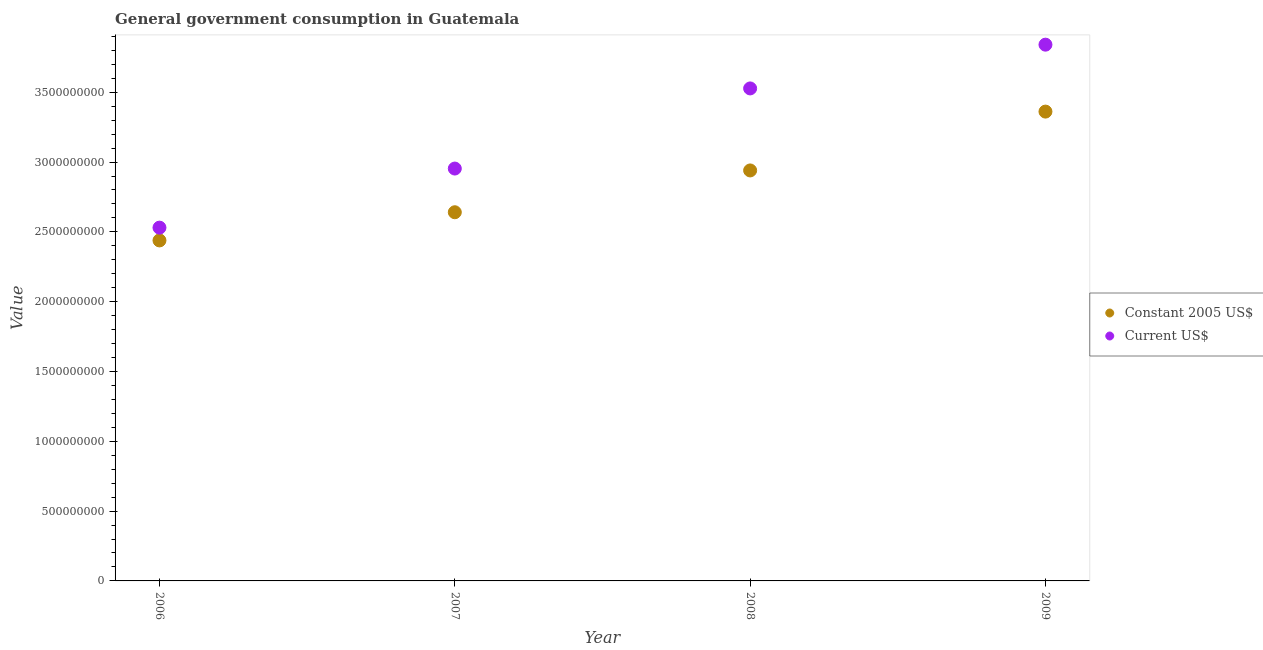What is the value consumed in current us$ in 2006?
Keep it short and to the point. 2.53e+09. Across all years, what is the maximum value consumed in constant 2005 us$?
Your response must be concise. 3.36e+09. Across all years, what is the minimum value consumed in constant 2005 us$?
Keep it short and to the point. 2.44e+09. In which year was the value consumed in current us$ maximum?
Provide a succinct answer. 2009. What is the total value consumed in constant 2005 us$ in the graph?
Provide a succinct answer. 1.14e+1. What is the difference between the value consumed in current us$ in 2006 and that in 2007?
Offer a very short reply. -4.23e+08. What is the difference between the value consumed in current us$ in 2007 and the value consumed in constant 2005 us$ in 2009?
Your answer should be very brief. -4.08e+08. What is the average value consumed in constant 2005 us$ per year?
Provide a short and direct response. 2.85e+09. In the year 2008, what is the difference between the value consumed in current us$ and value consumed in constant 2005 us$?
Your response must be concise. 5.87e+08. What is the ratio of the value consumed in constant 2005 us$ in 2008 to that in 2009?
Your answer should be compact. 0.87. Is the value consumed in current us$ in 2007 less than that in 2008?
Your answer should be very brief. Yes. Is the difference between the value consumed in constant 2005 us$ in 2006 and 2008 greater than the difference between the value consumed in current us$ in 2006 and 2008?
Provide a succinct answer. Yes. What is the difference between the highest and the second highest value consumed in constant 2005 us$?
Provide a short and direct response. 4.21e+08. What is the difference between the highest and the lowest value consumed in current us$?
Your response must be concise. 1.31e+09. In how many years, is the value consumed in current us$ greater than the average value consumed in current us$ taken over all years?
Offer a terse response. 2. Is the value consumed in current us$ strictly less than the value consumed in constant 2005 us$ over the years?
Make the answer very short. No. What is the difference between two consecutive major ticks on the Y-axis?
Your response must be concise. 5.00e+08. Are the values on the major ticks of Y-axis written in scientific E-notation?
Your answer should be compact. No. Does the graph contain grids?
Make the answer very short. No. Where does the legend appear in the graph?
Offer a very short reply. Center right. How many legend labels are there?
Offer a very short reply. 2. What is the title of the graph?
Keep it short and to the point. General government consumption in Guatemala. What is the label or title of the X-axis?
Give a very brief answer. Year. What is the label or title of the Y-axis?
Your answer should be compact. Value. What is the Value of Constant 2005 US$ in 2006?
Offer a terse response. 2.44e+09. What is the Value in Current US$ in 2006?
Give a very brief answer. 2.53e+09. What is the Value of Constant 2005 US$ in 2007?
Make the answer very short. 2.64e+09. What is the Value of Current US$ in 2007?
Ensure brevity in your answer.  2.95e+09. What is the Value of Constant 2005 US$ in 2008?
Offer a very short reply. 2.94e+09. What is the Value of Current US$ in 2008?
Your answer should be compact. 3.53e+09. What is the Value in Constant 2005 US$ in 2009?
Offer a terse response. 3.36e+09. What is the Value in Current US$ in 2009?
Your answer should be very brief. 3.84e+09. Across all years, what is the maximum Value in Constant 2005 US$?
Your answer should be very brief. 3.36e+09. Across all years, what is the maximum Value in Current US$?
Offer a terse response. 3.84e+09. Across all years, what is the minimum Value in Constant 2005 US$?
Give a very brief answer. 2.44e+09. Across all years, what is the minimum Value in Current US$?
Make the answer very short. 2.53e+09. What is the total Value of Constant 2005 US$ in the graph?
Your answer should be compact. 1.14e+1. What is the total Value in Current US$ in the graph?
Ensure brevity in your answer.  1.29e+1. What is the difference between the Value in Constant 2005 US$ in 2006 and that in 2007?
Make the answer very short. -2.02e+08. What is the difference between the Value in Current US$ in 2006 and that in 2007?
Make the answer very short. -4.23e+08. What is the difference between the Value of Constant 2005 US$ in 2006 and that in 2008?
Your answer should be very brief. -5.01e+08. What is the difference between the Value in Current US$ in 2006 and that in 2008?
Your answer should be very brief. -9.97e+08. What is the difference between the Value of Constant 2005 US$ in 2006 and that in 2009?
Offer a terse response. -9.23e+08. What is the difference between the Value of Current US$ in 2006 and that in 2009?
Keep it short and to the point. -1.31e+09. What is the difference between the Value of Constant 2005 US$ in 2007 and that in 2008?
Make the answer very short. -2.99e+08. What is the difference between the Value in Current US$ in 2007 and that in 2008?
Make the answer very short. -5.74e+08. What is the difference between the Value in Constant 2005 US$ in 2007 and that in 2009?
Ensure brevity in your answer.  -7.21e+08. What is the difference between the Value of Current US$ in 2007 and that in 2009?
Your answer should be compact. -8.87e+08. What is the difference between the Value in Constant 2005 US$ in 2008 and that in 2009?
Keep it short and to the point. -4.21e+08. What is the difference between the Value in Current US$ in 2008 and that in 2009?
Offer a terse response. -3.13e+08. What is the difference between the Value of Constant 2005 US$ in 2006 and the Value of Current US$ in 2007?
Provide a short and direct response. -5.15e+08. What is the difference between the Value in Constant 2005 US$ in 2006 and the Value in Current US$ in 2008?
Offer a very short reply. -1.09e+09. What is the difference between the Value of Constant 2005 US$ in 2006 and the Value of Current US$ in 2009?
Offer a terse response. -1.40e+09. What is the difference between the Value in Constant 2005 US$ in 2007 and the Value in Current US$ in 2008?
Your answer should be compact. -8.87e+08. What is the difference between the Value of Constant 2005 US$ in 2007 and the Value of Current US$ in 2009?
Ensure brevity in your answer.  -1.20e+09. What is the difference between the Value of Constant 2005 US$ in 2008 and the Value of Current US$ in 2009?
Provide a succinct answer. -9.01e+08. What is the average Value of Constant 2005 US$ per year?
Provide a short and direct response. 2.85e+09. What is the average Value in Current US$ per year?
Offer a very short reply. 3.21e+09. In the year 2006, what is the difference between the Value in Constant 2005 US$ and Value in Current US$?
Make the answer very short. -9.16e+07. In the year 2007, what is the difference between the Value of Constant 2005 US$ and Value of Current US$?
Offer a terse response. -3.13e+08. In the year 2008, what is the difference between the Value in Constant 2005 US$ and Value in Current US$?
Your answer should be compact. -5.87e+08. In the year 2009, what is the difference between the Value in Constant 2005 US$ and Value in Current US$?
Your response must be concise. -4.79e+08. What is the ratio of the Value in Constant 2005 US$ in 2006 to that in 2007?
Ensure brevity in your answer.  0.92. What is the ratio of the Value in Current US$ in 2006 to that in 2007?
Give a very brief answer. 0.86. What is the ratio of the Value of Constant 2005 US$ in 2006 to that in 2008?
Make the answer very short. 0.83. What is the ratio of the Value of Current US$ in 2006 to that in 2008?
Your response must be concise. 0.72. What is the ratio of the Value of Constant 2005 US$ in 2006 to that in 2009?
Ensure brevity in your answer.  0.73. What is the ratio of the Value of Current US$ in 2006 to that in 2009?
Your answer should be very brief. 0.66. What is the ratio of the Value of Constant 2005 US$ in 2007 to that in 2008?
Give a very brief answer. 0.9. What is the ratio of the Value of Current US$ in 2007 to that in 2008?
Keep it short and to the point. 0.84. What is the ratio of the Value of Constant 2005 US$ in 2007 to that in 2009?
Offer a terse response. 0.79. What is the ratio of the Value of Current US$ in 2007 to that in 2009?
Offer a very short reply. 0.77. What is the ratio of the Value in Constant 2005 US$ in 2008 to that in 2009?
Offer a terse response. 0.87. What is the ratio of the Value of Current US$ in 2008 to that in 2009?
Offer a very short reply. 0.92. What is the difference between the highest and the second highest Value of Constant 2005 US$?
Ensure brevity in your answer.  4.21e+08. What is the difference between the highest and the second highest Value in Current US$?
Make the answer very short. 3.13e+08. What is the difference between the highest and the lowest Value in Constant 2005 US$?
Make the answer very short. 9.23e+08. What is the difference between the highest and the lowest Value in Current US$?
Provide a short and direct response. 1.31e+09. 